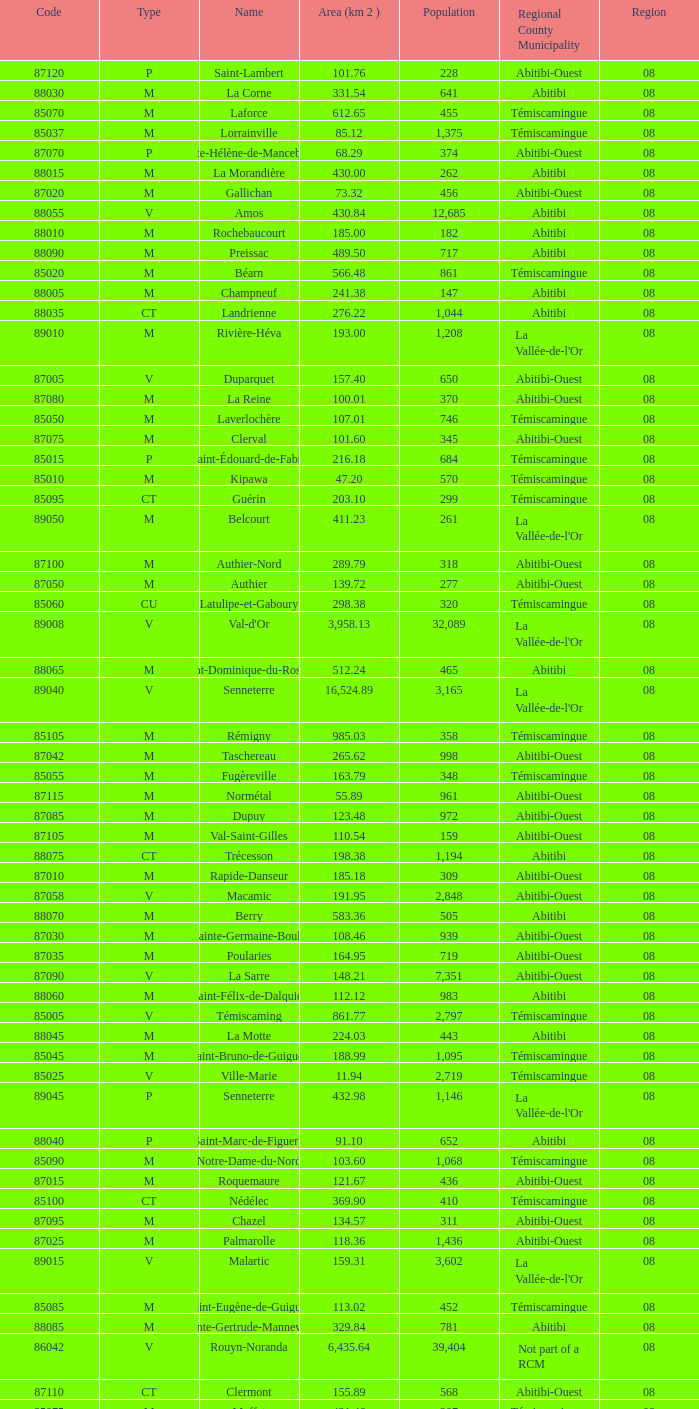What type has a population of 370? M. 